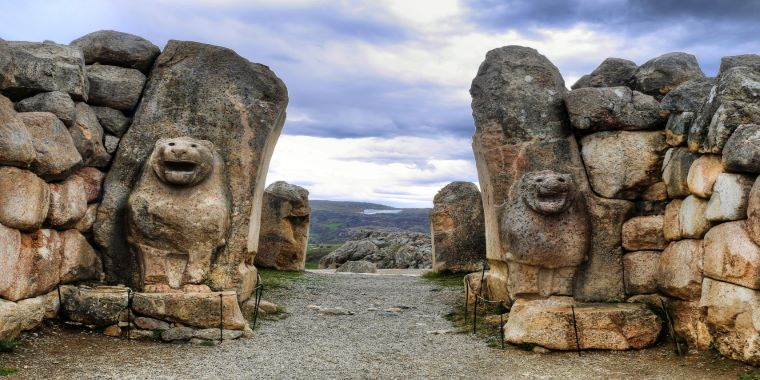What unique features of Hittite architecture are evident in the construction of the Lion Gate? The Lion Gate of Hattusa showcases several quintessential features of Hittite architecture. The use of massive limestone blocks in a dry-stone construction is indicative of their engineering prowess. The meticulous fitting of these blocks ensures stability and durability. The integration of sculptural art, particularly the lion reliefs, into the structural elements demonstrates a blend of functionality and aesthetics. Additionally, the gate's strategic location and its monumental scale reflect the Hittites' emphasis on impressive and defensible urban planning. This synthesis of artistry and engineering is a hallmark of Hittite architectural innovation. 